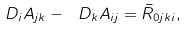Convert formula to latex. <formula><loc_0><loc_0><loc_500><loc_500>\ D _ { i } A _ { j k } - \ D _ { k } A _ { i j } = \bar { R } _ { 0 j k i } ,</formula> 